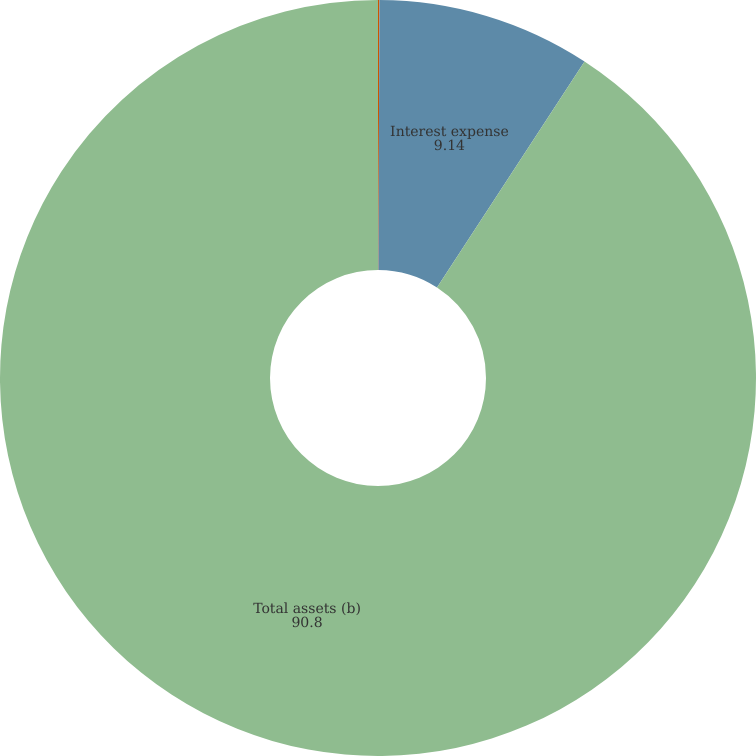Convert chart to OTSL. <chart><loc_0><loc_0><loc_500><loc_500><pie_chart><fcel>Interest and dividend income<fcel>Interest expense<fcel>Total assets (b)<nl><fcel>0.06%<fcel>9.14%<fcel>90.8%<nl></chart> 